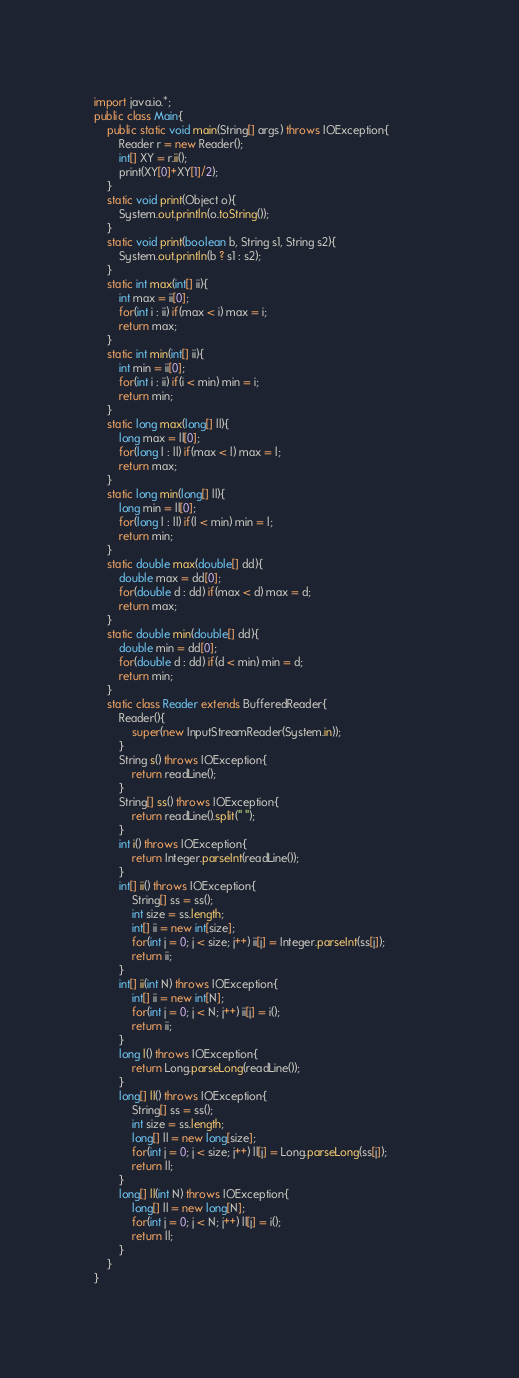Convert code to text. <code><loc_0><loc_0><loc_500><loc_500><_Java_>import java.io.*;
public class Main{
    public static void main(String[] args) throws IOException{
        Reader r = new Reader();        
        int[] XY = r.ii();
        print(XY[0]+XY[1]/2);
    }
    static void print(Object o){
        System.out.println(o.toString());
    }
    static void print(boolean b, String s1, String s2){
        System.out.println(b ? s1 : s2);
    }
    static int max(int[] ii){
        int max = ii[0];
        for(int i : ii) if(max < i) max = i;
        return max;
    }
    static int min(int[] ii){
        int min = ii[0];
        for(int i : ii) if(i < min) min = i;
        return min;
    }
    static long max(long[] ll){
        long max = ll[0];
        for(long l : ll) if(max < l) max = l;     
        return max;
    }
    static long min(long[] ll){
        long min = ll[0];
        for(long l : ll) if(l < min) min = l;
        return min;
    }
    static double max(double[] dd){
        double max = dd[0];
        for(double d : dd) if(max < d) max = d;
        return max;
    }
    static double min(double[] dd){
        double min = dd[0];
        for(double d : dd) if(d < min) min = d;
        return min;
    }
    static class Reader extends BufferedReader{
        Reader(){
            super(new InputStreamReader(System.in));
        }
        String s() throws IOException{
            return readLine();
        }
        String[] ss() throws IOException{
            return readLine().split(" ");
        }
        int i() throws IOException{
            return Integer.parseInt(readLine());
        }
        int[] ii() throws IOException{
            String[] ss = ss();
            int size = ss.length;
            int[] ii = new int[size];
            for(int j = 0; j < size; j++) ii[j] = Integer.parseInt(ss[j]);
            return ii;
        }
        int[] ii(int N) throws IOException{
            int[] ii = new int[N];
            for(int j = 0; j < N; j++) ii[j] = i();
            return ii;
        }
        long l() throws IOException{
            return Long.parseLong(readLine());
        }
        long[] ll() throws IOException{
            String[] ss = ss();
            int size = ss.length;
            long[] ll = new long[size];
            for(int j = 0; j < size; j++) ll[j] = Long.parseLong(ss[j]);            
            return ll;
        }
        long[] ll(int N) throws IOException{
            long[] ll = new long[N];
            for(int j = 0; j < N; j++) ll[j] = i();            
            return ll;
        }
    }
}</code> 